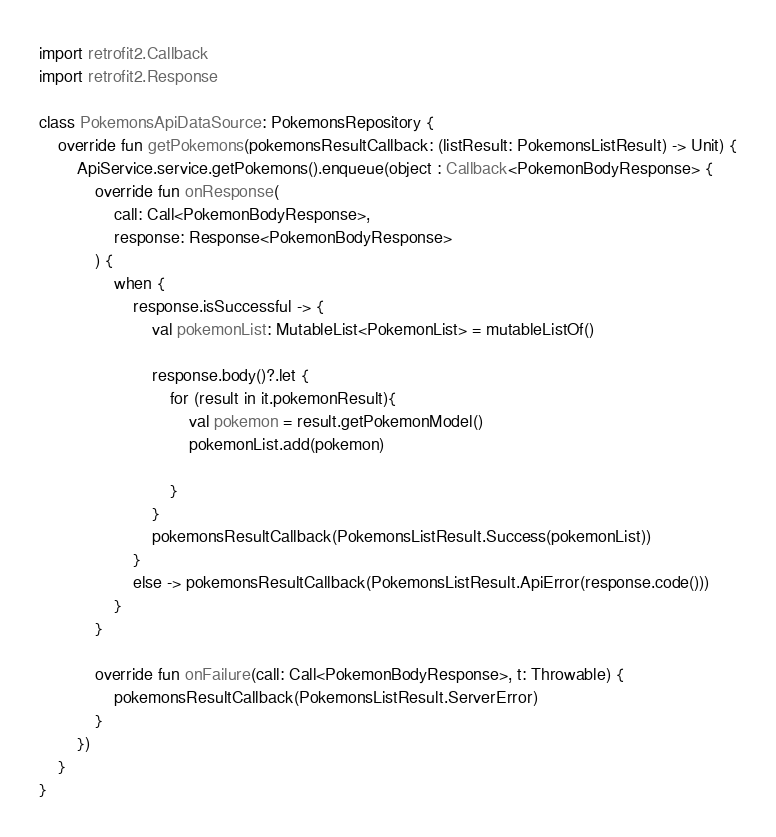Convert code to text. <code><loc_0><loc_0><loc_500><loc_500><_Kotlin_>import retrofit2.Callback
import retrofit2.Response

class PokemonsApiDataSource: PokemonsRepository {
    override fun getPokemons(pokemonsResultCallback: (listResult: PokemonsListResult) -> Unit) {
        ApiService.service.getPokemons().enqueue(object : Callback<PokemonBodyResponse> {
            override fun onResponse(
                call: Call<PokemonBodyResponse>,
                response: Response<PokemonBodyResponse>
            ) {
                when {
                    response.isSuccessful -> {
                        val pokemonList: MutableList<PokemonList> = mutableListOf()

                        response.body()?.let {
                            for (result in it.pokemonResult){
                                val pokemon = result.getPokemonModel()
                                pokemonList.add(pokemon)

                            }
                        }
                        pokemonsResultCallback(PokemonsListResult.Success(pokemonList))
                    }
                    else -> pokemonsResultCallback(PokemonsListResult.ApiError(response.code()))
                }
            }

            override fun onFailure(call: Call<PokemonBodyResponse>, t: Throwable) {
                pokemonsResultCallback(PokemonsListResult.ServerError)
            }
        })
    }
}</code> 